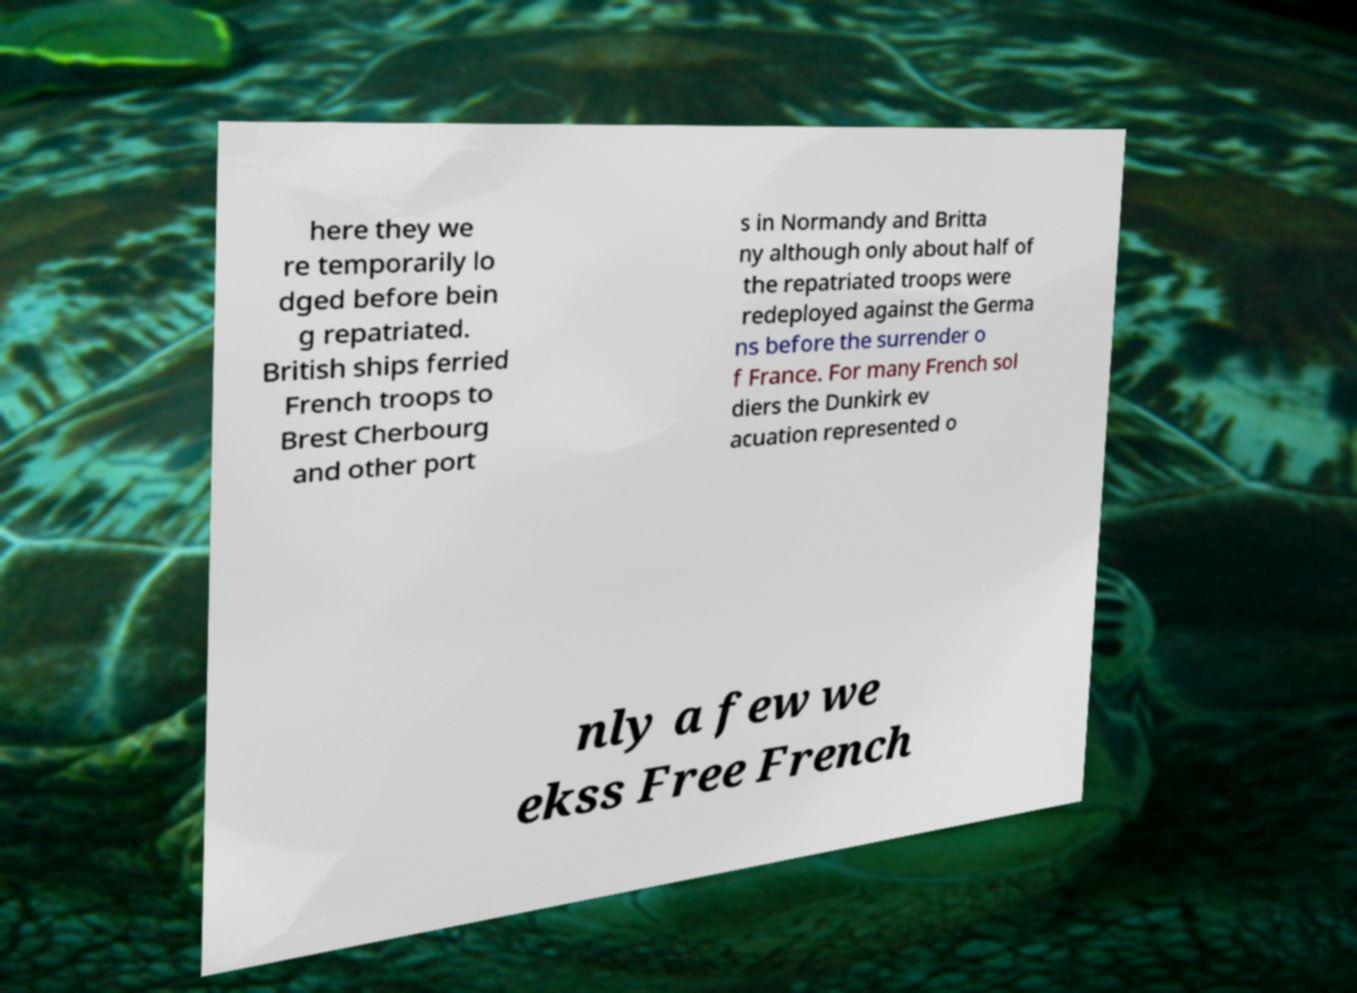Could you extract and type out the text from this image? here they we re temporarily lo dged before bein g repatriated. British ships ferried French troops to Brest Cherbourg and other port s in Normandy and Britta ny although only about half of the repatriated troops were redeployed against the Germa ns before the surrender o f France. For many French sol diers the Dunkirk ev acuation represented o nly a few we ekss Free French 